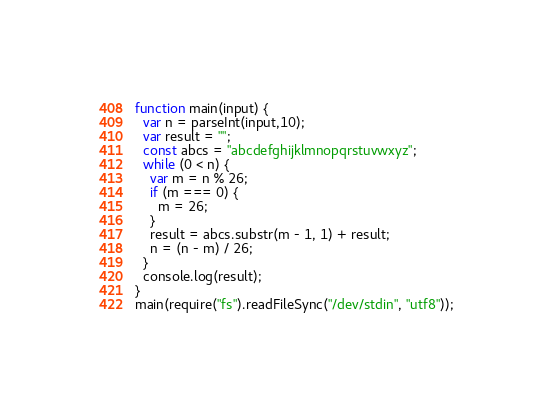<code> <loc_0><loc_0><loc_500><loc_500><_JavaScript_>function main(input) {
  var n = parseInt(input,10);
  var result = "";
  const abcs = "abcdefghijklmnopqrstuvwxyz";
  while (0 < n) {
    var m = n % 26;
    if (m === 0) {
      m = 26;
    }
    result = abcs.substr(m - 1, 1) + result;
    n = (n - m) / 26;
  }
  console.log(result);
}
main(require("fs").readFileSync("/dev/stdin", "utf8"));
</code> 